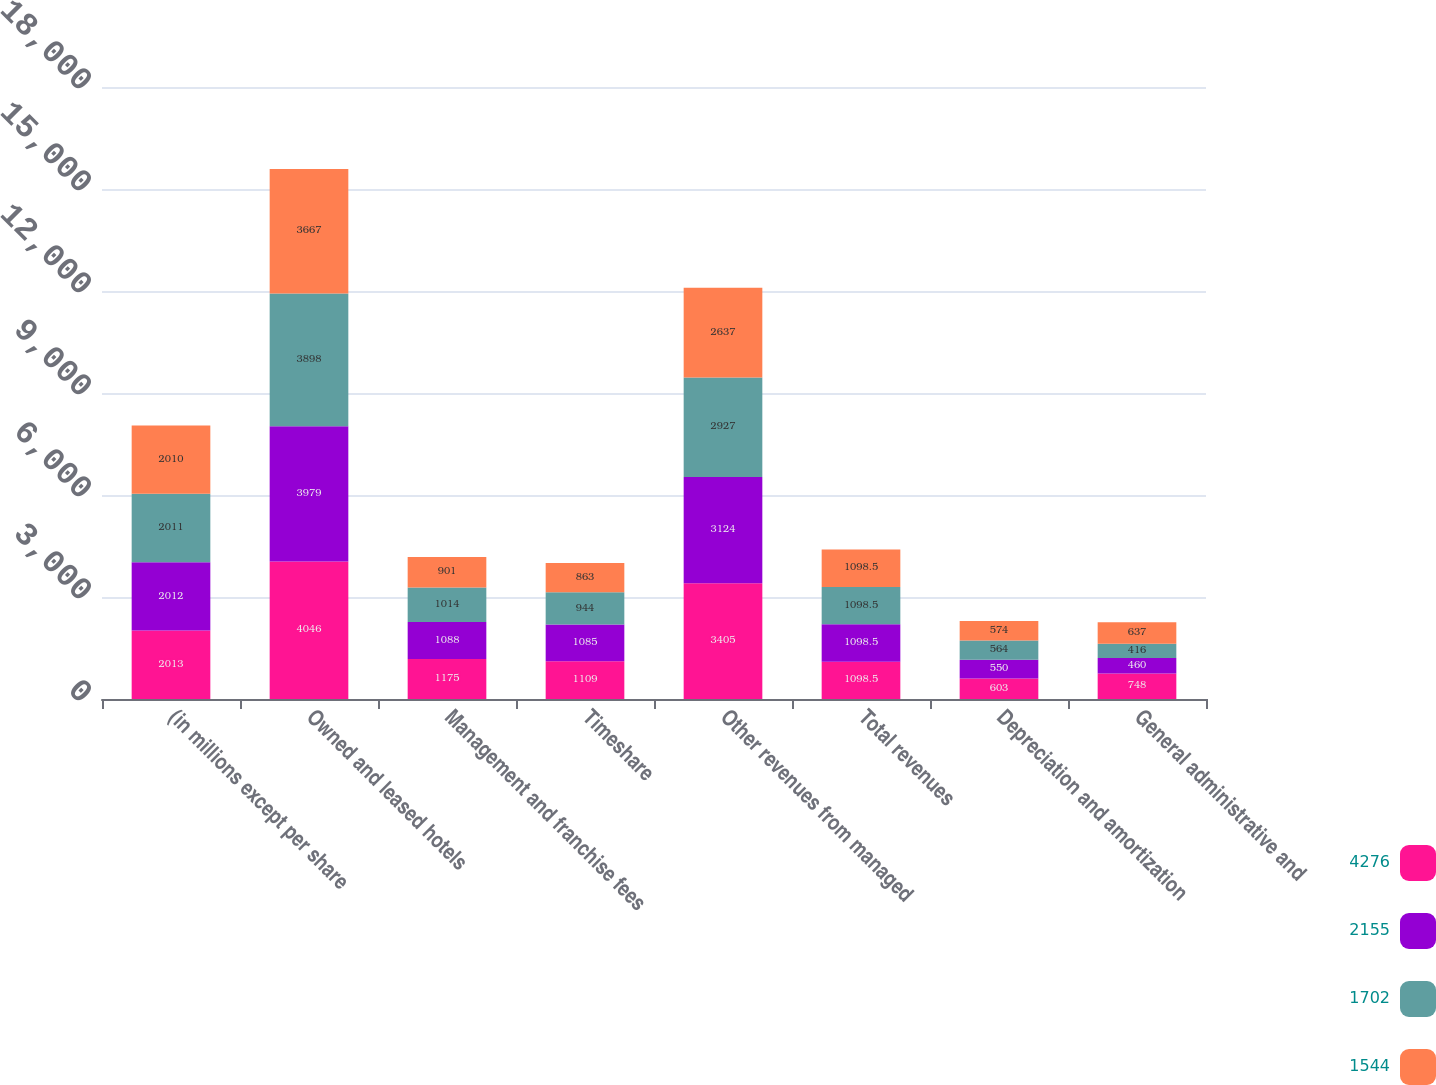Convert chart to OTSL. <chart><loc_0><loc_0><loc_500><loc_500><stacked_bar_chart><ecel><fcel>(in millions except per share<fcel>Owned and leased hotels<fcel>Management and franchise fees<fcel>Timeshare<fcel>Other revenues from managed<fcel>Total revenues<fcel>Depreciation and amortization<fcel>General administrative and<nl><fcel>4276<fcel>2013<fcel>4046<fcel>1175<fcel>1109<fcel>3405<fcel>1098.5<fcel>603<fcel>748<nl><fcel>2155<fcel>2012<fcel>3979<fcel>1088<fcel>1085<fcel>3124<fcel>1098.5<fcel>550<fcel>460<nl><fcel>1702<fcel>2011<fcel>3898<fcel>1014<fcel>944<fcel>2927<fcel>1098.5<fcel>564<fcel>416<nl><fcel>1544<fcel>2010<fcel>3667<fcel>901<fcel>863<fcel>2637<fcel>1098.5<fcel>574<fcel>637<nl></chart> 